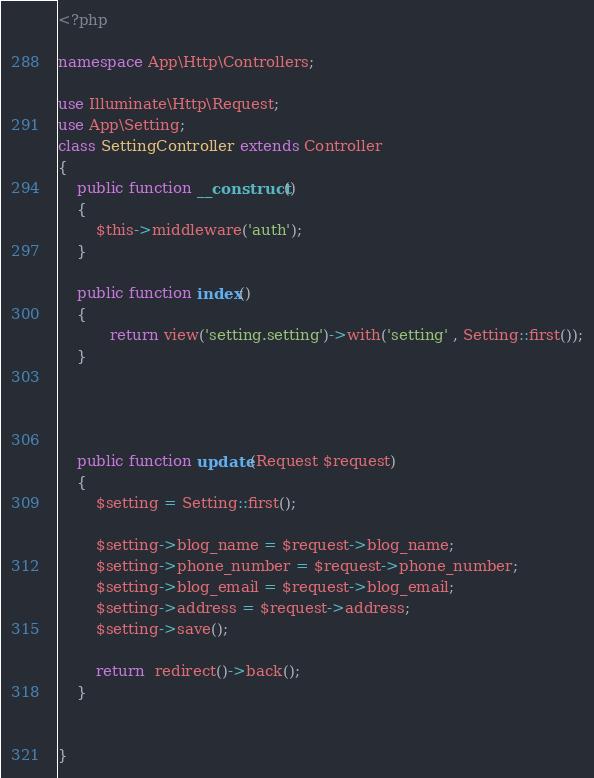<code> <loc_0><loc_0><loc_500><loc_500><_PHP_><?php

namespace App\Http\Controllers;

use Illuminate\Http\Request;
use App\Setting;
class SettingController extends Controller
{
    public function __construct()
    {
        $this->middleware('auth');
    }

    public function index()
    {
           return view('setting.setting')->with('setting' , Setting::first());
    }




    public function update(Request $request)
    {
        $setting = Setting::first();

        $setting->blog_name = $request->blog_name;
        $setting->phone_number = $request->phone_number;
        $setting->blog_email = $request->blog_email;
        $setting->address = $request->address;
        $setting->save();

        return  redirect()->back();
    }


}
</code> 